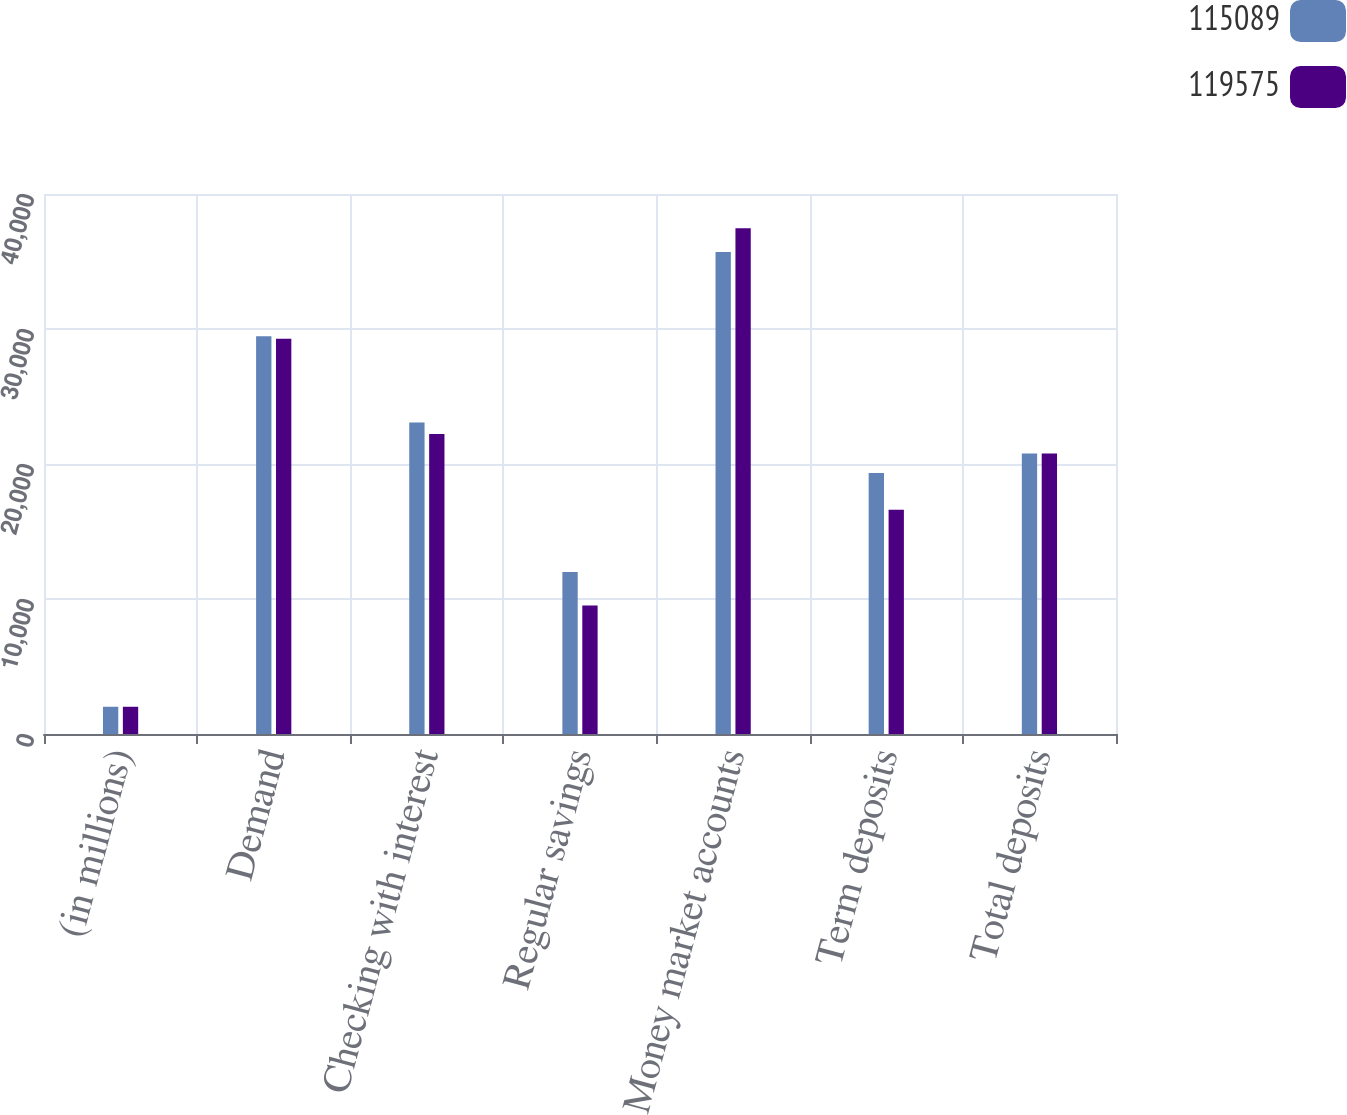Convert chart. <chart><loc_0><loc_0><loc_500><loc_500><stacked_bar_chart><ecel><fcel>(in millions)<fcel>Demand<fcel>Checking with interest<fcel>Regular savings<fcel>Money market accounts<fcel>Term deposits<fcel>Total deposits<nl><fcel>115089<fcel>2018<fcel>29458<fcel>23067<fcel>12007<fcel>35701<fcel>19342<fcel>20785.5<nl><fcel>119575<fcel>2017<fcel>29279<fcel>22229<fcel>9518<fcel>37454<fcel>16609<fcel>20785.5<nl></chart> 